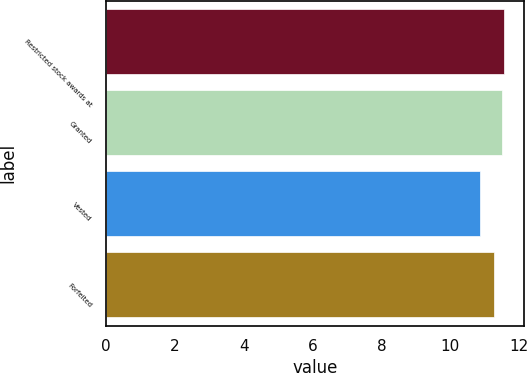<chart> <loc_0><loc_0><loc_500><loc_500><bar_chart><fcel>Restricted stock awards at<fcel>Granted<fcel>Vested<fcel>Forfeited<nl><fcel>11.56<fcel>11.49<fcel>10.87<fcel>11.27<nl></chart> 